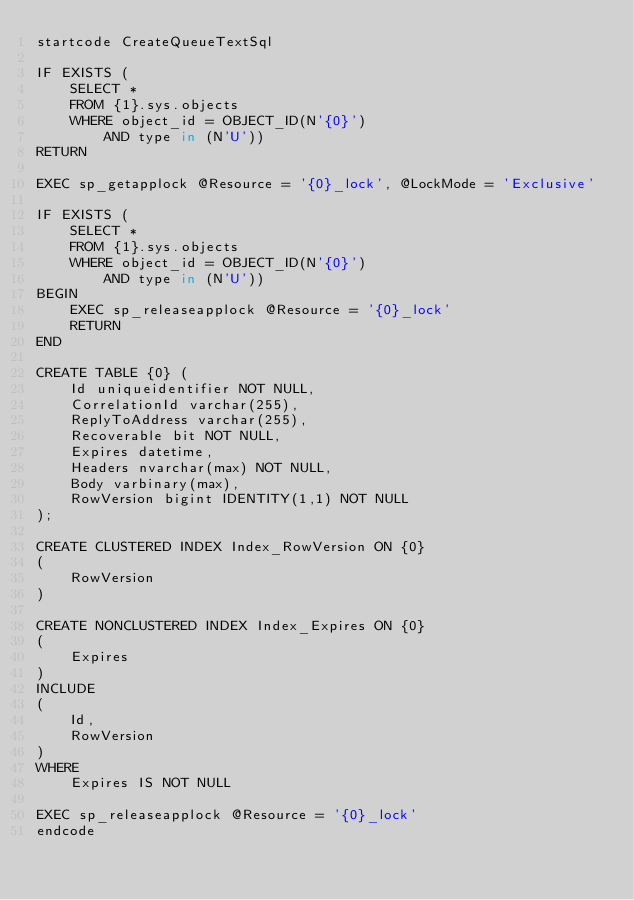Convert code to text. <code><loc_0><loc_0><loc_500><loc_500><_SQL_>startcode CreateQueueTextSql

IF EXISTS (
    SELECT *
    FROM {1}.sys.objects
    WHERE object_id = OBJECT_ID(N'{0}')
        AND type in (N'U'))
RETURN

EXEC sp_getapplock @Resource = '{0}_lock', @LockMode = 'Exclusive'

IF EXISTS (
    SELECT *
    FROM {1}.sys.objects
    WHERE object_id = OBJECT_ID(N'{0}')
        AND type in (N'U'))
BEGIN
    EXEC sp_releaseapplock @Resource = '{0}_lock'
    RETURN
END

CREATE TABLE {0} (
    Id uniqueidentifier NOT NULL,
    CorrelationId varchar(255),
    ReplyToAddress varchar(255),
    Recoverable bit NOT NULL,
    Expires datetime,
    Headers nvarchar(max) NOT NULL,
    Body varbinary(max),
    RowVersion bigint IDENTITY(1,1) NOT NULL
);

CREATE CLUSTERED INDEX Index_RowVersion ON {0}
(
    RowVersion
)

CREATE NONCLUSTERED INDEX Index_Expires ON {0}
(
    Expires
)
INCLUDE
(
    Id,
    RowVersion
)
WHERE
    Expires IS NOT NULL

EXEC sp_releaseapplock @Resource = '{0}_lock'
endcode
</code> 